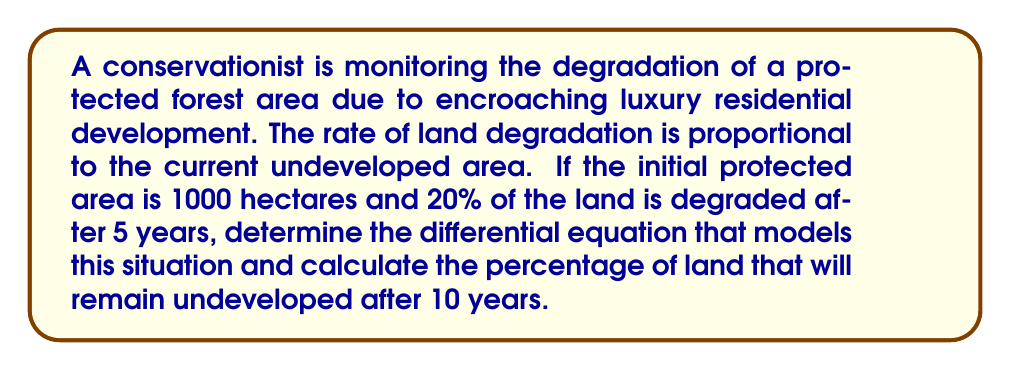Could you help me with this problem? Let's approach this step-by-step:

1) Let $A(t)$ be the undeveloped area at time $t$ in years.

2) The rate of land degradation is proportional to the current undeveloped area. This can be modeled by the differential equation:

   $$\frac{dA}{dt} = -kA$$

   where $k$ is the degradation rate constant.

3) The solution to this differential equation is:

   $$A(t) = A_0e^{-kt}$$

   where $A_0$ is the initial area.

4) We know that $A_0 = 1000$ hectares and after 5 years, 80% of the land remains undeveloped. We can use this to find $k$:

   $$800 = 1000e^{-5k}$$

5) Solving for $k$:

   $$\ln(0.8) = -5k$$
   $$k = -\frac{\ln(0.8)}{5} \approx 0.0446$$

6) Now we have the complete model:

   $$A(t) = 1000e^{-0.0446t}$$

7) To find the percentage of land remaining after 10 years, we calculate:

   $$A(10) = 1000e^{-0.0446 * 10} \approx 639.73$$

8) The percentage remaining is:

   $$\frac{639.73}{1000} * 100\% \approx 63.97\%$$

Therefore, approximately 63.97% of the land will remain undeveloped after 10 years.
Answer: 63.97% 